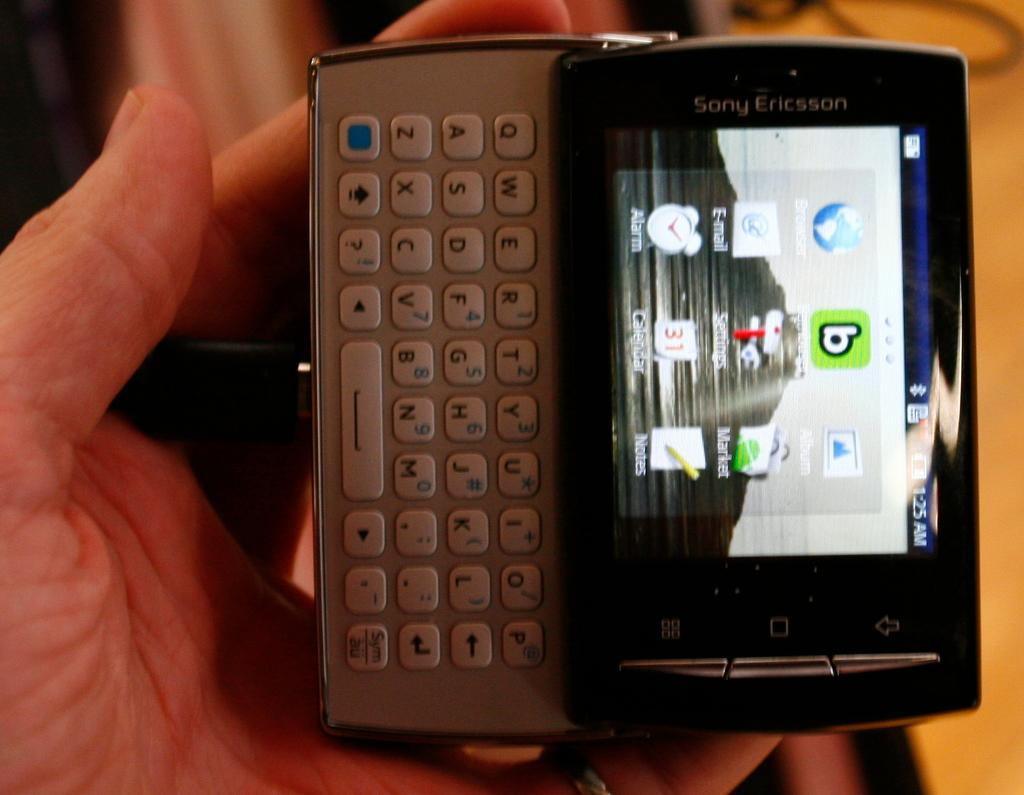<image>
Render a clear and concise summary of the photo. A small Sony Ericsson slide phone that is open to the home screen. 